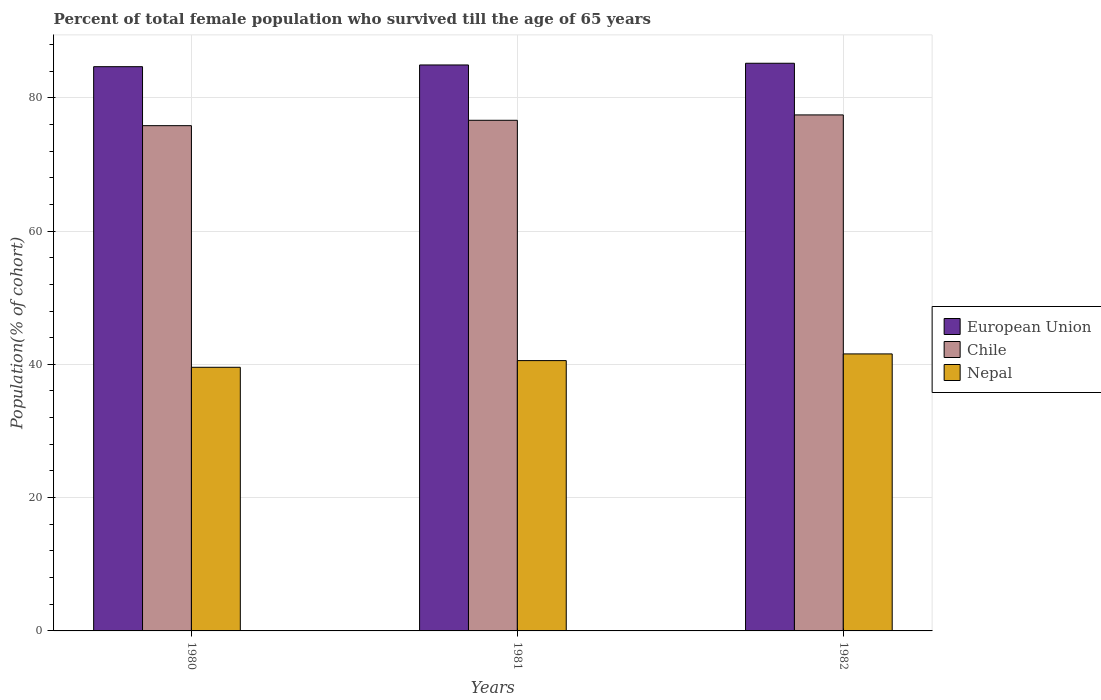How many different coloured bars are there?
Make the answer very short. 3. How many groups of bars are there?
Offer a very short reply. 3. Are the number of bars per tick equal to the number of legend labels?
Provide a short and direct response. Yes. Are the number of bars on each tick of the X-axis equal?
Ensure brevity in your answer.  Yes. How many bars are there on the 3rd tick from the left?
Provide a succinct answer. 3. What is the percentage of total female population who survived till the age of 65 years in European Union in 1980?
Offer a terse response. 84.66. Across all years, what is the maximum percentage of total female population who survived till the age of 65 years in Chile?
Keep it short and to the point. 77.42. Across all years, what is the minimum percentage of total female population who survived till the age of 65 years in Chile?
Your answer should be very brief. 75.81. In which year was the percentage of total female population who survived till the age of 65 years in European Union maximum?
Your response must be concise. 1982. What is the total percentage of total female population who survived till the age of 65 years in European Union in the graph?
Give a very brief answer. 254.75. What is the difference between the percentage of total female population who survived till the age of 65 years in European Union in 1980 and that in 1981?
Your answer should be compact. -0.26. What is the difference between the percentage of total female population who survived till the age of 65 years in European Union in 1982 and the percentage of total female population who survived till the age of 65 years in Nepal in 1980?
Give a very brief answer. 45.62. What is the average percentage of total female population who survived till the age of 65 years in European Union per year?
Give a very brief answer. 84.92. In the year 1980, what is the difference between the percentage of total female population who survived till the age of 65 years in Nepal and percentage of total female population who survived till the age of 65 years in Chile?
Your answer should be very brief. -36.25. What is the ratio of the percentage of total female population who survived till the age of 65 years in Nepal in 1980 to that in 1981?
Offer a very short reply. 0.98. What is the difference between the highest and the second highest percentage of total female population who survived till the age of 65 years in European Union?
Keep it short and to the point. 0.26. What is the difference between the highest and the lowest percentage of total female population who survived till the age of 65 years in Nepal?
Offer a terse response. 2.01. What does the 1st bar from the left in 1980 represents?
Give a very brief answer. European Union. What does the 1st bar from the right in 1980 represents?
Your answer should be compact. Nepal. How many bars are there?
Give a very brief answer. 9. Are all the bars in the graph horizontal?
Offer a terse response. No. What is the difference between two consecutive major ticks on the Y-axis?
Give a very brief answer. 20. Does the graph contain grids?
Offer a very short reply. Yes. How are the legend labels stacked?
Offer a terse response. Vertical. What is the title of the graph?
Your answer should be compact. Percent of total female population who survived till the age of 65 years. Does "Belize" appear as one of the legend labels in the graph?
Offer a very short reply. No. What is the label or title of the Y-axis?
Keep it short and to the point. Population(% of cohort). What is the Population(% of cohort) of European Union in 1980?
Ensure brevity in your answer.  84.66. What is the Population(% of cohort) of Chile in 1980?
Your answer should be compact. 75.81. What is the Population(% of cohort) in Nepal in 1980?
Give a very brief answer. 39.56. What is the Population(% of cohort) in European Union in 1981?
Your answer should be very brief. 84.92. What is the Population(% of cohort) in Chile in 1981?
Your answer should be very brief. 76.62. What is the Population(% of cohort) in Nepal in 1981?
Make the answer very short. 40.56. What is the Population(% of cohort) in European Union in 1982?
Keep it short and to the point. 85.17. What is the Population(% of cohort) in Chile in 1982?
Make the answer very short. 77.42. What is the Population(% of cohort) of Nepal in 1982?
Give a very brief answer. 41.56. Across all years, what is the maximum Population(% of cohort) in European Union?
Your answer should be compact. 85.17. Across all years, what is the maximum Population(% of cohort) in Chile?
Make the answer very short. 77.42. Across all years, what is the maximum Population(% of cohort) of Nepal?
Provide a succinct answer. 41.56. Across all years, what is the minimum Population(% of cohort) in European Union?
Ensure brevity in your answer.  84.66. Across all years, what is the minimum Population(% of cohort) in Chile?
Ensure brevity in your answer.  75.81. Across all years, what is the minimum Population(% of cohort) of Nepal?
Keep it short and to the point. 39.56. What is the total Population(% of cohort) of European Union in the graph?
Your response must be concise. 254.75. What is the total Population(% of cohort) of Chile in the graph?
Keep it short and to the point. 229.85. What is the total Population(% of cohort) in Nepal in the graph?
Make the answer very short. 121.68. What is the difference between the Population(% of cohort) in European Union in 1980 and that in 1981?
Offer a very short reply. -0.26. What is the difference between the Population(% of cohort) in Chile in 1980 and that in 1981?
Ensure brevity in your answer.  -0.81. What is the difference between the Population(% of cohort) of Nepal in 1980 and that in 1981?
Offer a terse response. -1. What is the difference between the Population(% of cohort) of European Union in 1980 and that in 1982?
Make the answer very short. -0.51. What is the difference between the Population(% of cohort) in Chile in 1980 and that in 1982?
Provide a succinct answer. -1.61. What is the difference between the Population(% of cohort) in Nepal in 1980 and that in 1982?
Provide a short and direct response. -2.01. What is the difference between the Population(% of cohort) of European Union in 1981 and that in 1982?
Your answer should be very brief. -0.26. What is the difference between the Population(% of cohort) in Chile in 1981 and that in 1982?
Keep it short and to the point. -0.81. What is the difference between the Population(% of cohort) in Nepal in 1981 and that in 1982?
Make the answer very short. -1. What is the difference between the Population(% of cohort) in European Union in 1980 and the Population(% of cohort) in Chile in 1981?
Offer a terse response. 8.04. What is the difference between the Population(% of cohort) of European Union in 1980 and the Population(% of cohort) of Nepal in 1981?
Provide a short and direct response. 44.1. What is the difference between the Population(% of cohort) of Chile in 1980 and the Population(% of cohort) of Nepal in 1981?
Keep it short and to the point. 35.25. What is the difference between the Population(% of cohort) in European Union in 1980 and the Population(% of cohort) in Chile in 1982?
Give a very brief answer. 7.24. What is the difference between the Population(% of cohort) in European Union in 1980 and the Population(% of cohort) in Nepal in 1982?
Provide a short and direct response. 43.1. What is the difference between the Population(% of cohort) of Chile in 1980 and the Population(% of cohort) of Nepal in 1982?
Offer a terse response. 34.25. What is the difference between the Population(% of cohort) in European Union in 1981 and the Population(% of cohort) in Chile in 1982?
Ensure brevity in your answer.  7.5. What is the difference between the Population(% of cohort) in European Union in 1981 and the Population(% of cohort) in Nepal in 1982?
Offer a terse response. 43.36. What is the difference between the Population(% of cohort) of Chile in 1981 and the Population(% of cohort) of Nepal in 1982?
Your answer should be compact. 35.05. What is the average Population(% of cohort) in European Union per year?
Ensure brevity in your answer.  84.92. What is the average Population(% of cohort) in Chile per year?
Ensure brevity in your answer.  76.62. What is the average Population(% of cohort) in Nepal per year?
Offer a terse response. 40.56. In the year 1980, what is the difference between the Population(% of cohort) in European Union and Population(% of cohort) in Chile?
Your answer should be very brief. 8.85. In the year 1980, what is the difference between the Population(% of cohort) of European Union and Population(% of cohort) of Nepal?
Provide a succinct answer. 45.1. In the year 1980, what is the difference between the Population(% of cohort) in Chile and Population(% of cohort) in Nepal?
Ensure brevity in your answer.  36.25. In the year 1981, what is the difference between the Population(% of cohort) of European Union and Population(% of cohort) of Chile?
Ensure brevity in your answer.  8.3. In the year 1981, what is the difference between the Population(% of cohort) of European Union and Population(% of cohort) of Nepal?
Your answer should be compact. 44.36. In the year 1981, what is the difference between the Population(% of cohort) of Chile and Population(% of cohort) of Nepal?
Your answer should be very brief. 36.06. In the year 1982, what is the difference between the Population(% of cohort) in European Union and Population(% of cohort) in Chile?
Your answer should be very brief. 7.75. In the year 1982, what is the difference between the Population(% of cohort) in European Union and Population(% of cohort) in Nepal?
Offer a very short reply. 43.61. In the year 1982, what is the difference between the Population(% of cohort) in Chile and Population(% of cohort) in Nepal?
Offer a very short reply. 35.86. What is the ratio of the Population(% of cohort) of Nepal in 1980 to that in 1981?
Your answer should be compact. 0.98. What is the ratio of the Population(% of cohort) in Chile in 1980 to that in 1982?
Provide a short and direct response. 0.98. What is the ratio of the Population(% of cohort) of Nepal in 1980 to that in 1982?
Your answer should be compact. 0.95. What is the ratio of the Population(% of cohort) in Nepal in 1981 to that in 1982?
Ensure brevity in your answer.  0.98. What is the difference between the highest and the second highest Population(% of cohort) of European Union?
Ensure brevity in your answer.  0.26. What is the difference between the highest and the second highest Population(% of cohort) of Chile?
Keep it short and to the point. 0.81. What is the difference between the highest and the lowest Population(% of cohort) of European Union?
Provide a succinct answer. 0.51. What is the difference between the highest and the lowest Population(% of cohort) of Chile?
Offer a terse response. 1.61. What is the difference between the highest and the lowest Population(% of cohort) in Nepal?
Give a very brief answer. 2.01. 